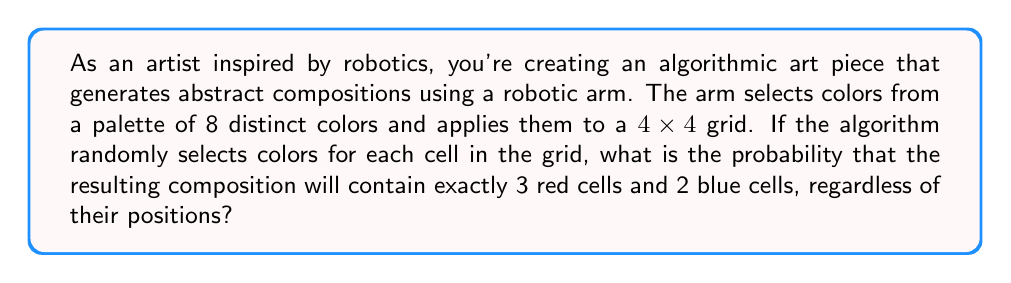Provide a solution to this math problem. To solve this problem, we'll use the concept of multinomial probability. Here's a step-by-step explanation:

1) First, we need to calculate the total number of cells in the grid:
   $4 \times 4 = 16$ cells

2) We're interested in a specific combination: 3 red cells, 2 blue cells, and the remaining 11 cells can be any of the other 6 colors.

3) The probability of selecting red for any single cell is $\frac{1}{8}$, and the same for blue.

4) For the remaining cells, the probability of selecting any non-red, non-blue color is $\frac{6}{8} = \frac{3}{4}$.

5) We can use the multinomial probability formula:

   $$P(X_1 = k_1, X_2 = k_2, ..., X_m = k_m) = \frac{n!}{k_1! k_2! ... k_m!} p_1^{k_1} p_2^{k_2} ... p_m^{k_m}$$

   Where:
   $n$ is the total number of trials (16 cells)
   $k_1, k_2, ..., k_m$ are the number of occurrences of each outcome
   $p_1, p_2, ..., p_m$ are the probabilities of each outcome

6) Plugging in our values:

   $$P(3\text{ red}, 2\text{ blue}, 11\text{ other}) = \frac{16!}{3!2!11!} \left(\frac{1}{8}\right)^3 \left(\frac{1}{8}\right)^2 \left(\frac{3}{4}\right)^{11}$$

7) Simplifying:

   $$P = \frac{16!}{3!2!11!} \cdot \frac{1}{8^5} \cdot \frac{3^{11}}{4^{11}}$$

8) Calculate the final probability:

   $$P \approx 0.0106$$
Answer: The probability of the algorithmic art piece containing exactly 3 red cells and 2 blue cells is approximately 0.0106 or 1.06%. 